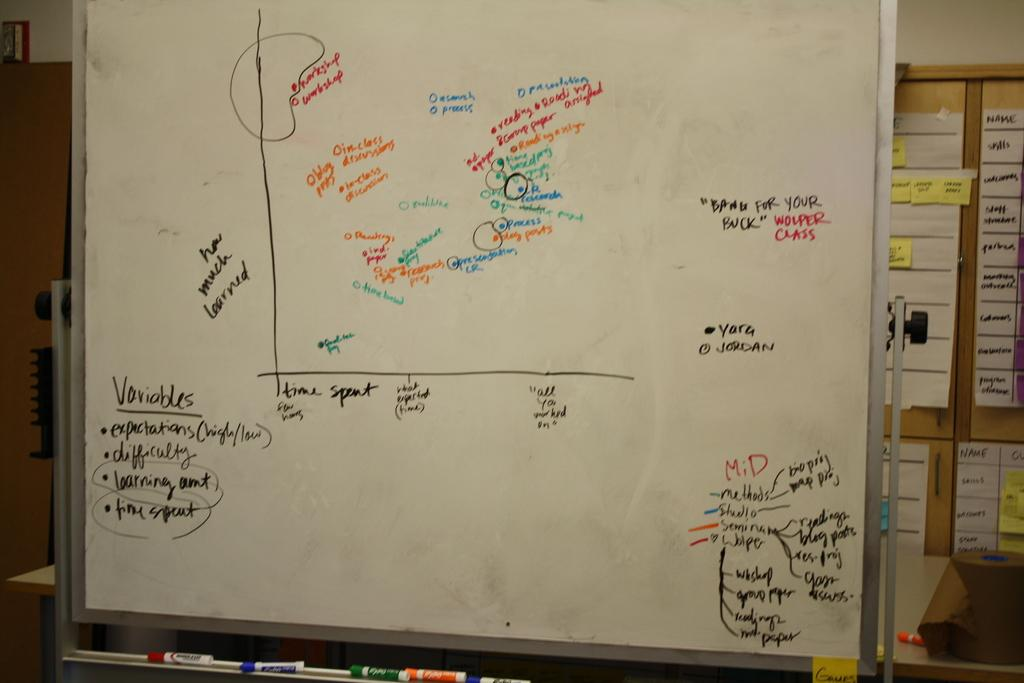<image>
Share a concise interpretation of the image provided. A whiteboard with a graph and many notes about the variables. 